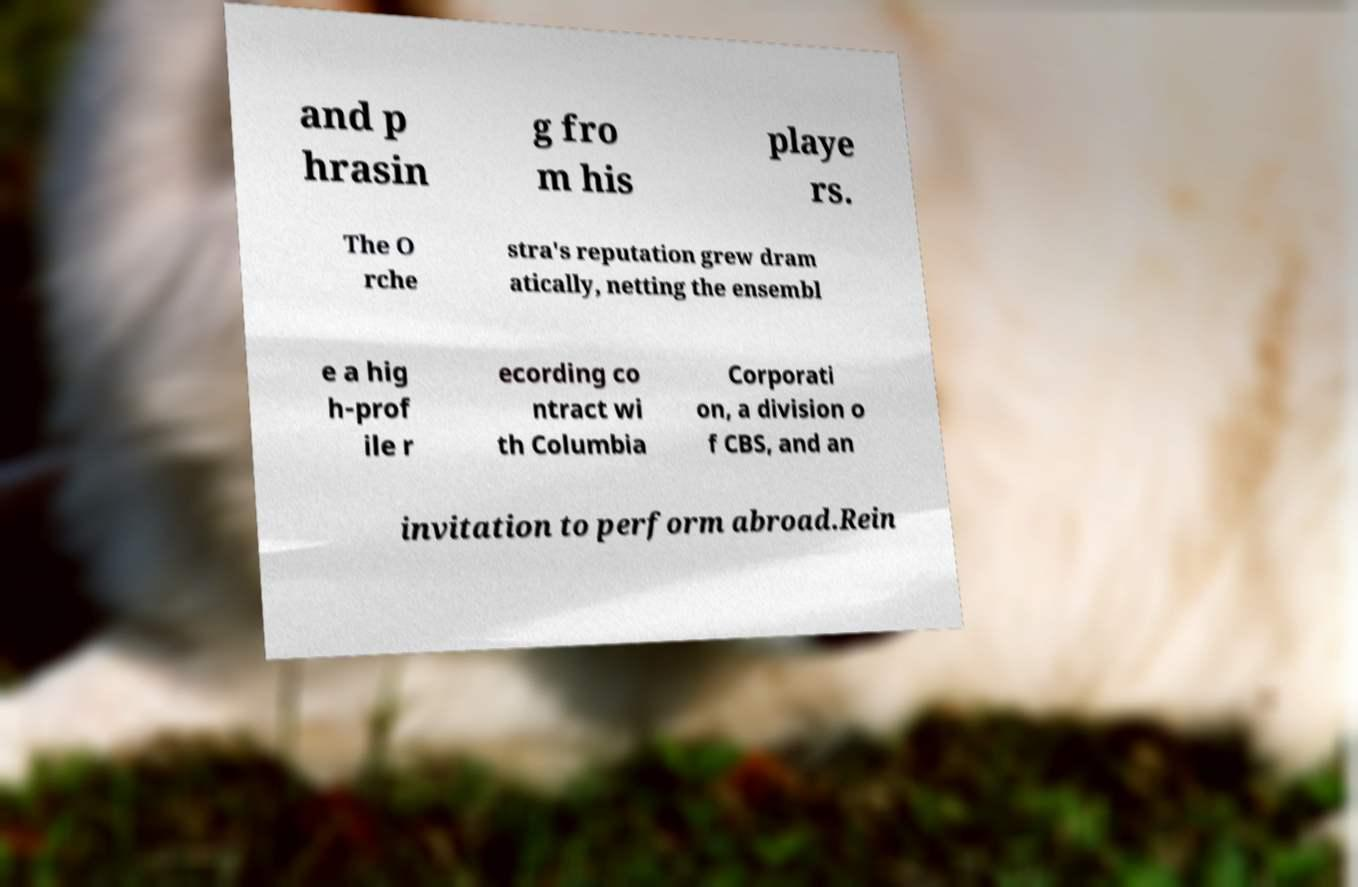Can you read and provide the text displayed in the image?This photo seems to have some interesting text. Can you extract and type it out for me? and p hrasin g fro m his playe rs. The O rche stra's reputation grew dram atically, netting the ensembl e a hig h-prof ile r ecording co ntract wi th Columbia Corporati on, a division o f CBS, and an invitation to perform abroad.Rein 